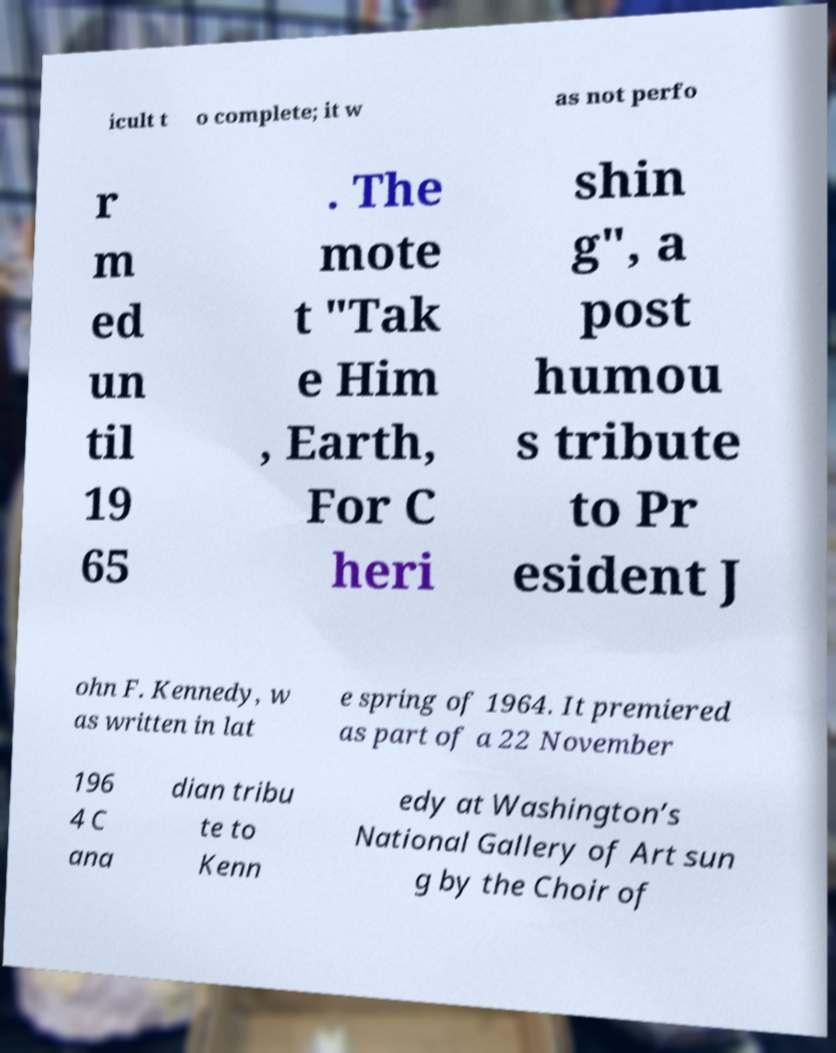What messages or text are displayed in this image? I need them in a readable, typed format. icult t o complete; it w as not perfo r m ed un til 19 65 . The mote t "Tak e Him , Earth, For C heri shin g", a post humou s tribute to Pr esident J ohn F. Kennedy, w as written in lat e spring of 1964. It premiered as part of a 22 November 196 4 C ana dian tribu te to Kenn edy at Washington’s National Gallery of Art sun g by the Choir of 